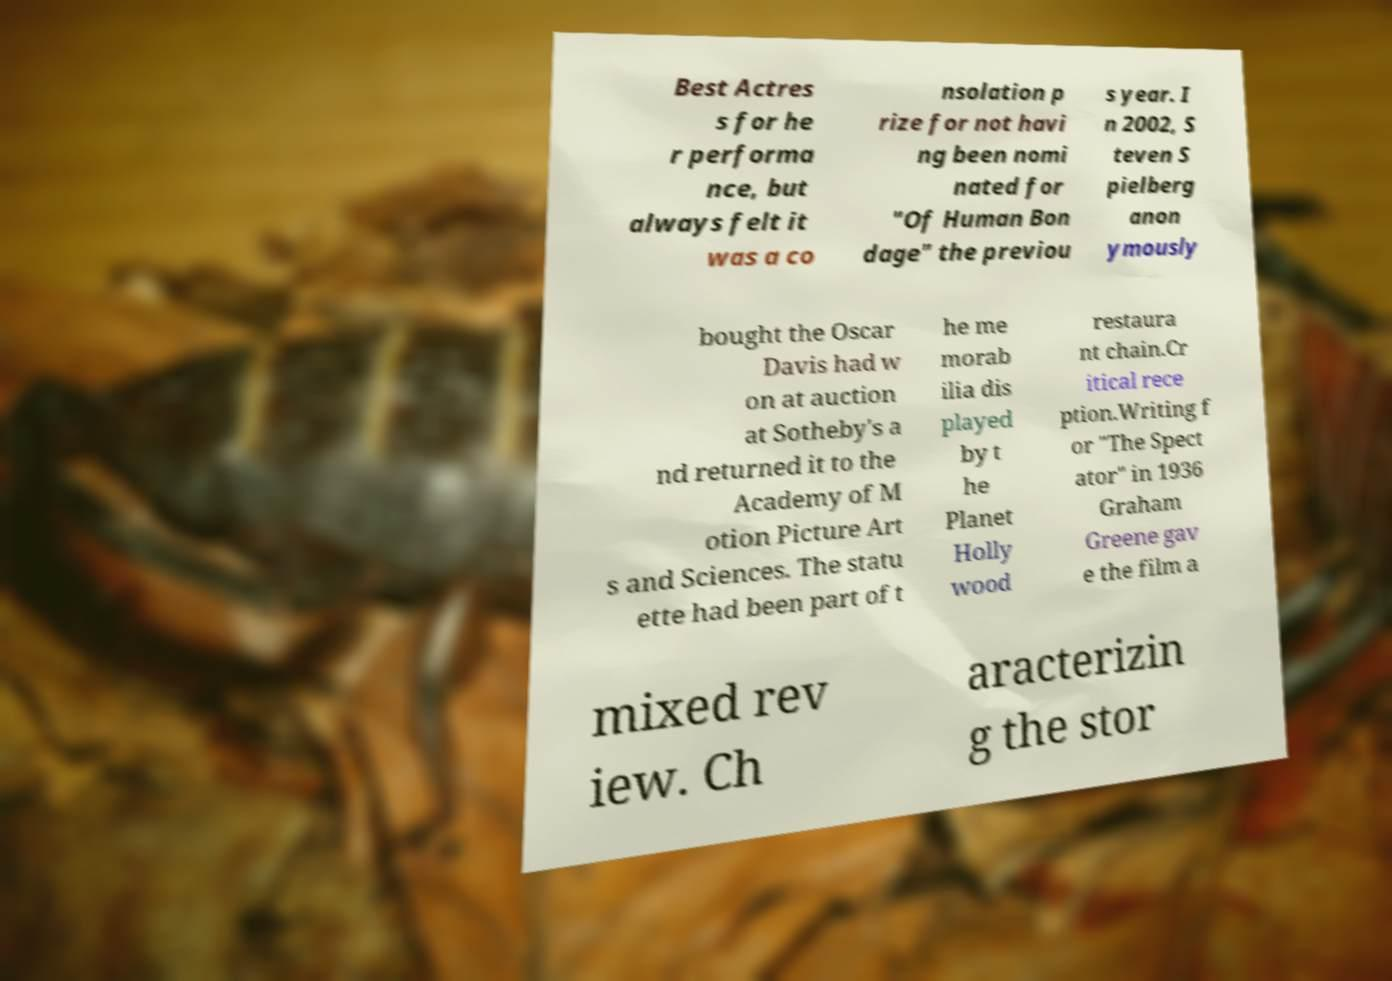Can you accurately transcribe the text from the provided image for me? Best Actres s for he r performa nce, but always felt it was a co nsolation p rize for not havi ng been nomi nated for "Of Human Bon dage" the previou s year. I n 2002, S teven S pielberg anon ymously bought the Oscar Davis had w on at auction at Sotheby's a nd returned it to the Academy of M otion Picture Art s and Sciences. The statu ette had been part of t he me morab ilia dis played by t he Planet Holly wood restaura nt chain.Cr itical rece ption.Writing f or "The Spect ator" in 1936 Graham Greene gav e the film a mixed rev iew. Ch aracterizin g the stor 